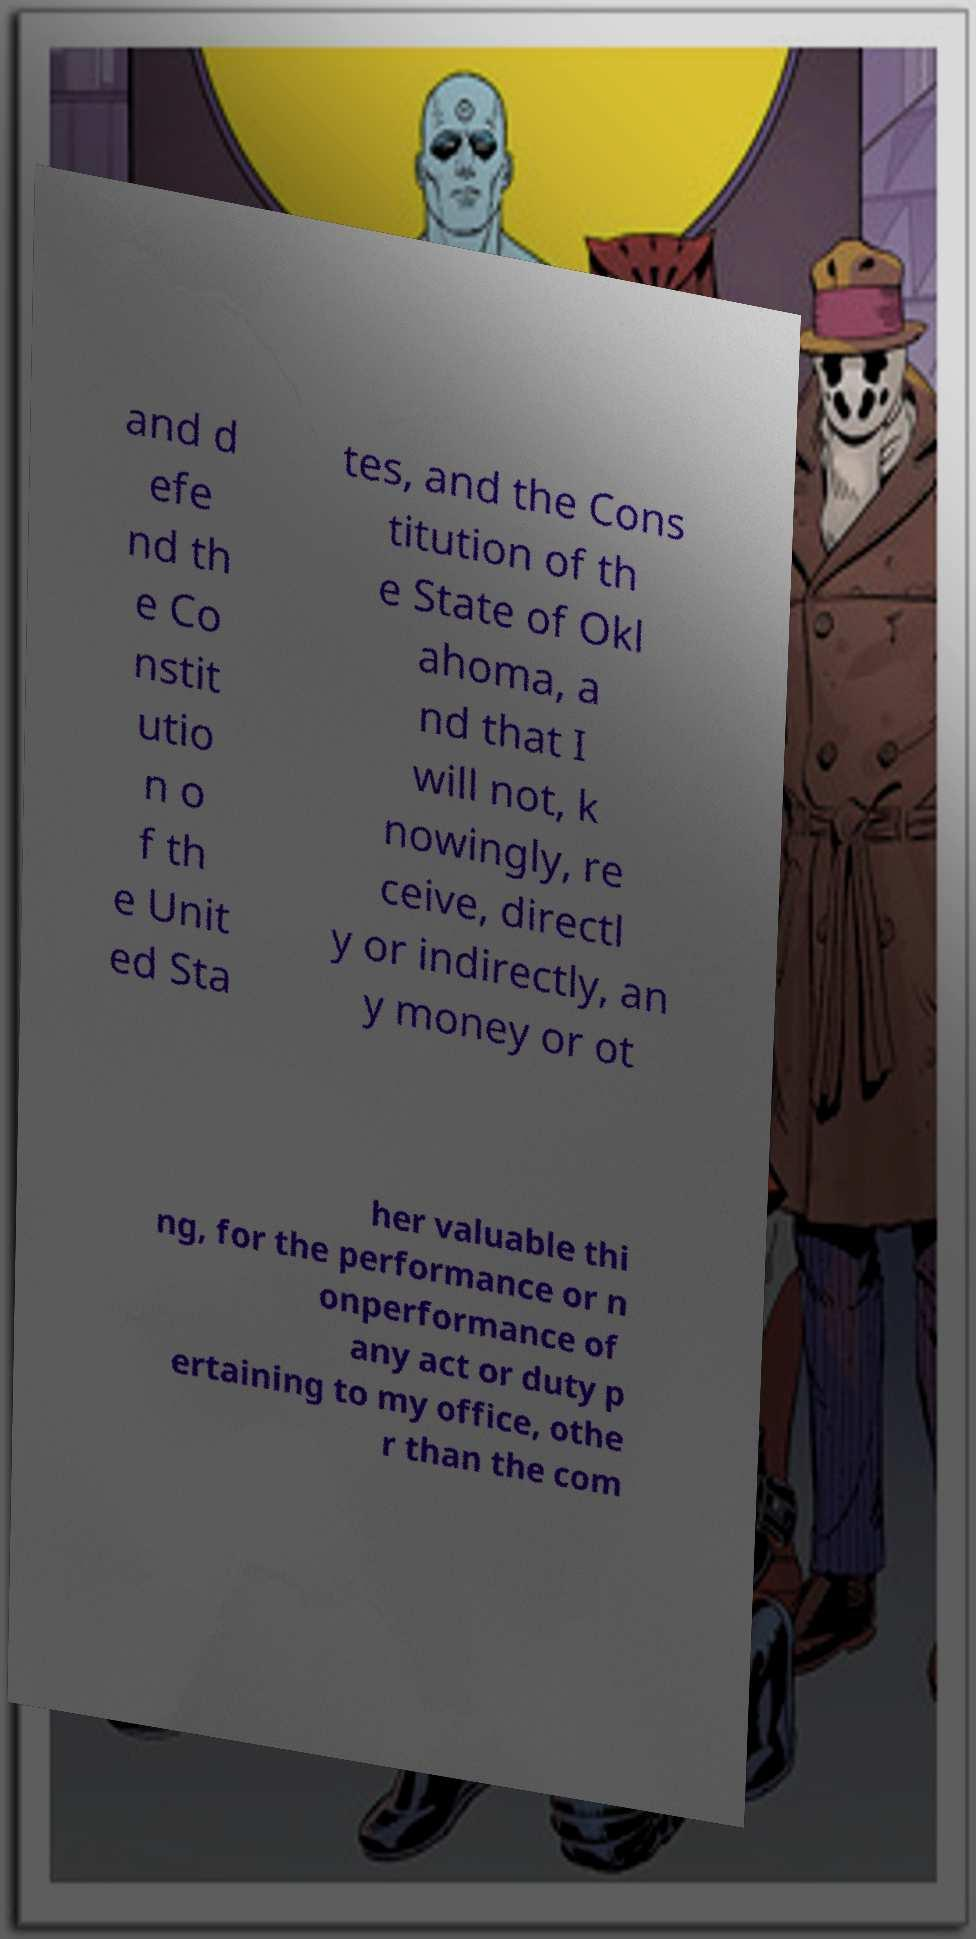There's text embedded in this image that I need extracted. Can you transcribe it verbatim? and d efe nd th e Co nstit utio n o f th e Unit ed Sta tes, and the Cons titution of th e State of Okl ahoma, a nd that I will not, k nowingly, re ceive, directl y or indirectly, an y money or ot her valuable thi ng, for the performance or n onperformance of any act or duty p ertaining to my office, othe r than the com 